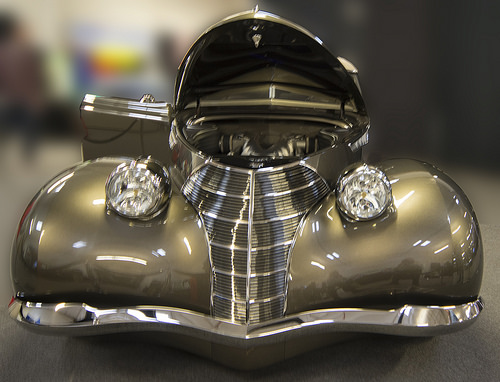<image>
Can you confirm if the light is above the car? No. The light is not positioned above the car. The vertical arrangement shows a different relationship. 